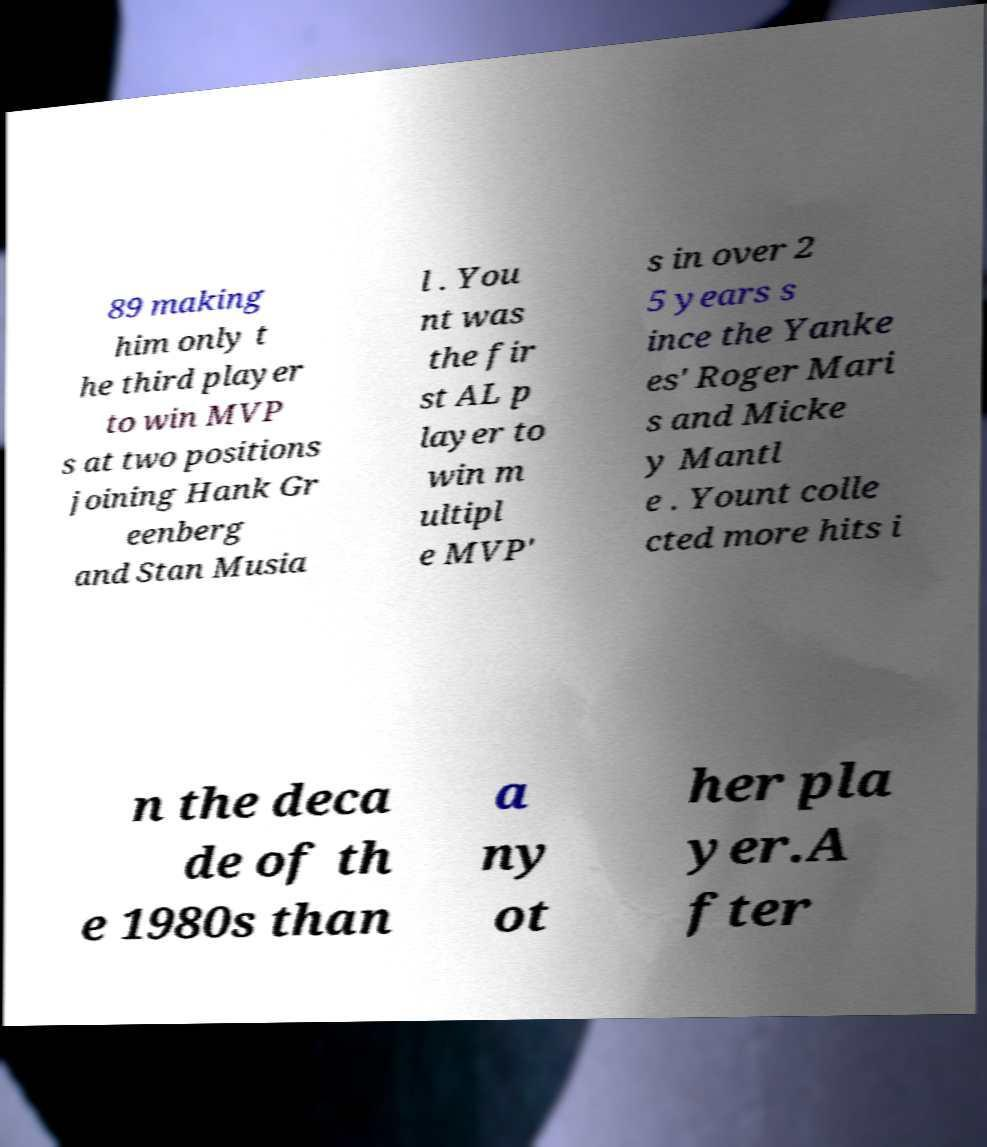Please read and relay the text visible in this image. What does it say? 89 making him only t he third player to win MVP s at two positions joining Hank Gr eenberg and Stan Musia l . You nt was the fir st AL p layer to win m ultipl e MVP' s in over 2 5 years s ince the Yanke es' Roger Mari s and Micke y Mantl e . Yount colle cted more hits i n the deca de of th e 1980s than a ny ot her pla yer.A fter 